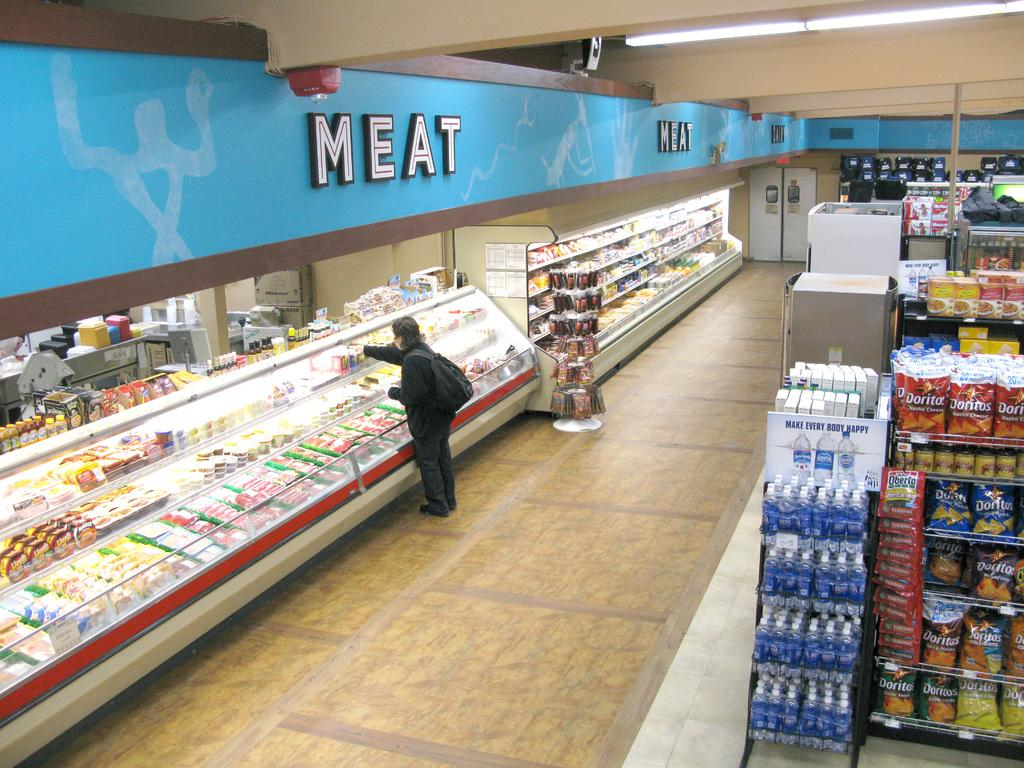<image>
Relay a brief, clear account of the picture shown. a pesron in the grocery store is looking in the meat counter 